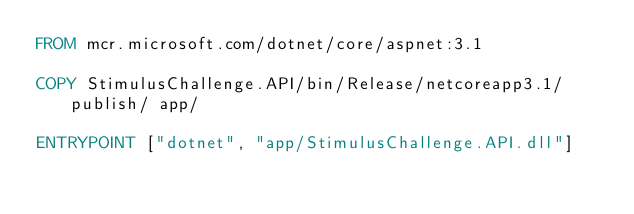Convert code to text. <code><loc_0><loc_0><loc_500><loc_500><_Dockerfile_>FROM mcr.microsoft.com/dotnet/core/aspnet:3.1

COPY StimulusChallenge.API/bin/Release/netcoreapp3.1/publish/ app/

ENTRYPOINT ["dotnet", "app/StimulusChallenge.API.dll"]</code> 